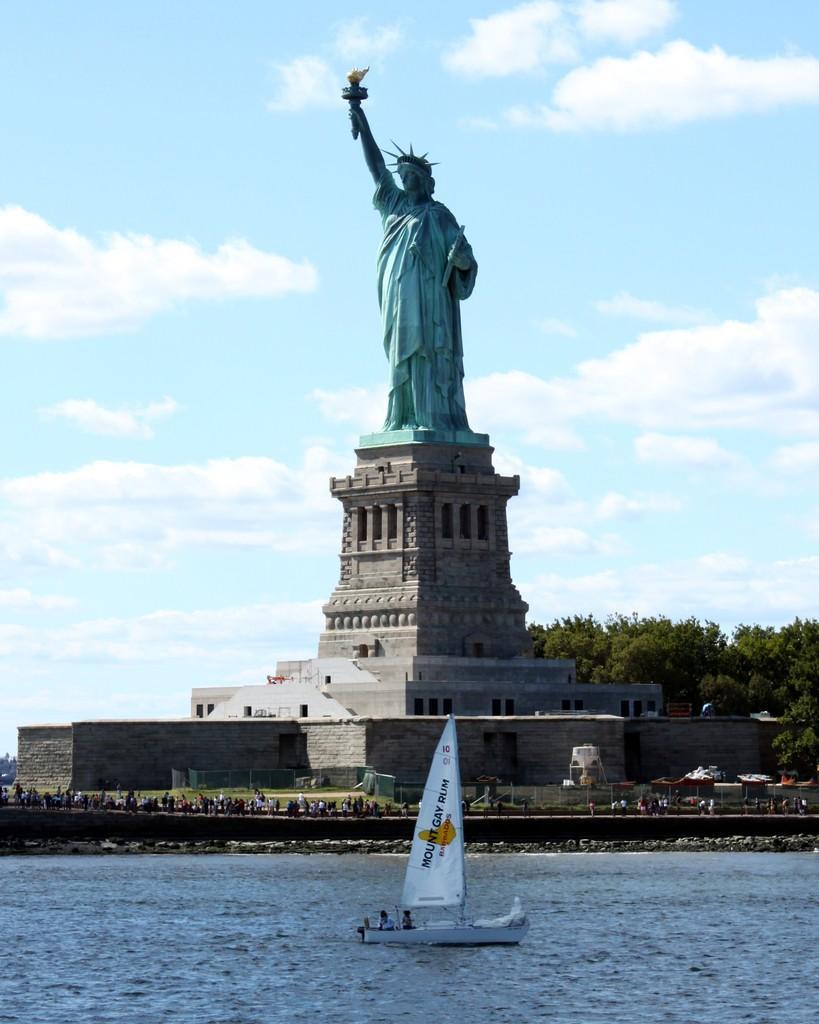How would you summarize this image in a sentence or two? In front of the image there is a boat in the water with two people in it, behind the water, there are a few people standing in front of the statue of liberty, behind the statue there are trees, at the top of the image there are clouds in the sky, in front of the statue of liberty there are tents, chairs and some other objects. 